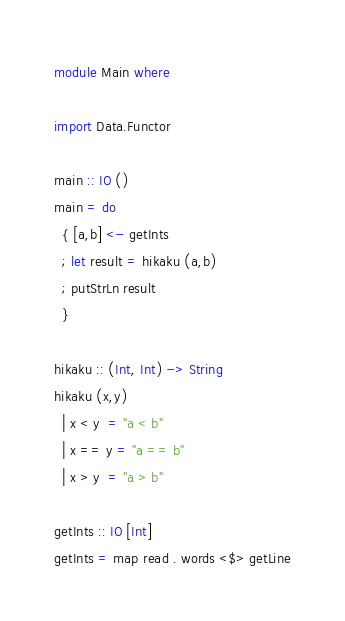<code> <loc_0><loc_0><loc_500><loc_500><_Haskell_>module Main where

import Data.Functor

main :: IO ()
main = do
  { [a,b] <- getInts
  ; let result = hikaku (a,b)
  ; putStrLn result
  }

hikaku :: (Int, Int) -> String
hikaku (x,y)
  | x < y  = "a < b"
  | x == y = "a == b"
  | x > y  = "a > b"

getInts :: IO [Int]
getInts = map read . words <$> getLine</code> 